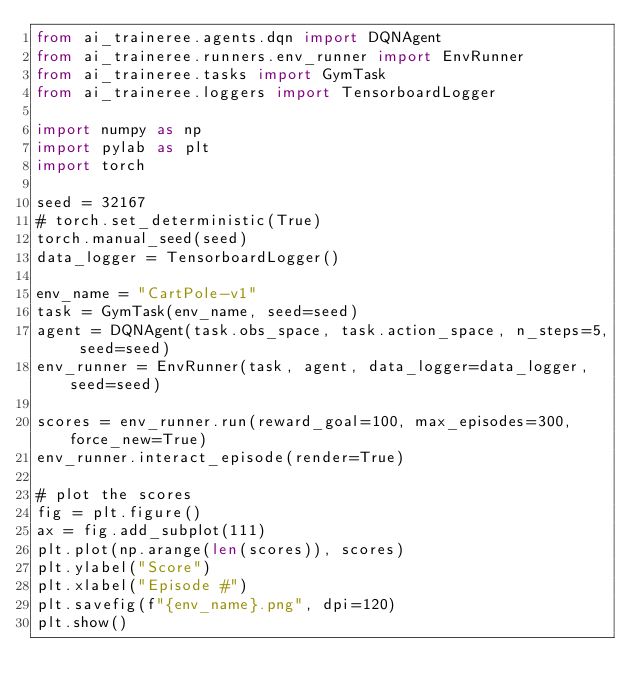<code> <loc_0><loc_0><loc_500><loc_500><_Python_>from ai_traineree.agents.dqn import DQNAgent
from ai_traineree.runners.env_runner import EnvRunner
from ai_traineree.tasks import GymTask
from ai_traineree.loggers import TensorboardLogger

import numpy as np
import pylab as plt
import torch

seed = 32167
# torch.set_deterministic(True)
torch.manual_seed(seed)
data_logger = TensorboardLogger()

env_name = "CartPole-v1"
task = GymTask(env_name, seed=seed)
agent = DQNAgent(task.obs_space, task.action_space, n_steps=5, seed=seed)
env_runner = EnvRunner(task, agent, data_logger=data_logger, seed=seed)

scores = env_runner.run(reward_goal=100, max_episodes=300, force_new=True)
env_runner.interact_episode(render=True)

# plot the scores
fig = plt.figure()
ax = fig.add_subplot(111)
plt.plot(np.arange(len(scores)), scores)
plt.ylabel("Score")
plt.xlabel("Episode #")
plt.savefig(f"{env_name}.png", dpi=120)
plt.show()
</code> 